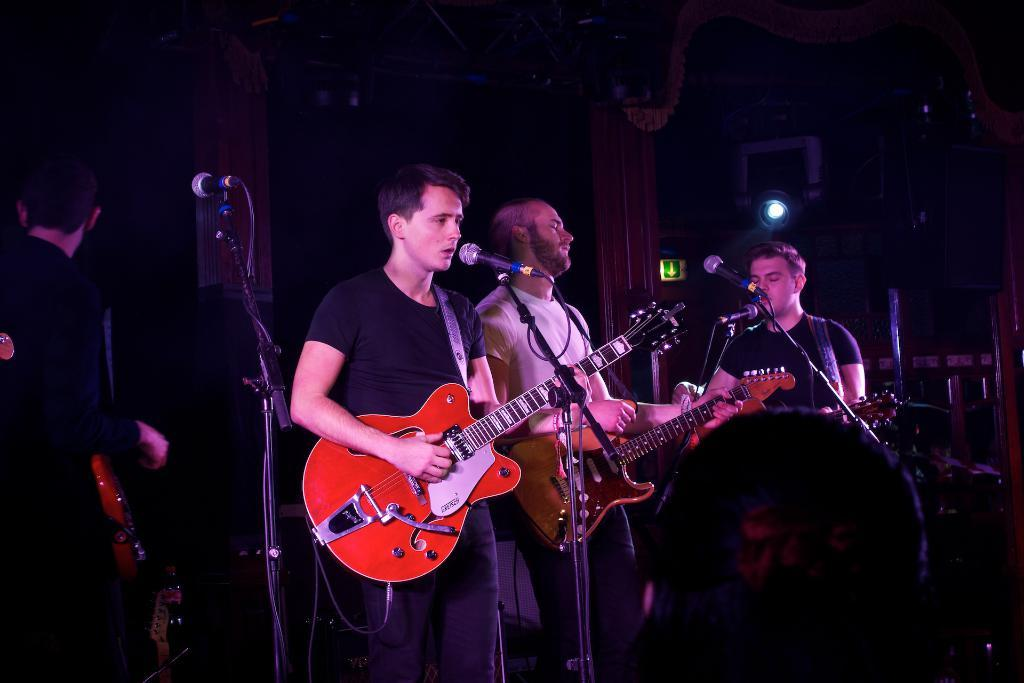What are the people in the image doing? There are people standing in the image, and some of them are playing guitar. Is there any vocalist in the image? Yes, there is a man singing in the image. How is the man singing? The man is using a microphone while singing. What type of drink is the man holding while singing? There is no drink visible in the image; the man is using a microphone while singing. Can you see any wax figures in the image? There are no wax figures present in the image; it features people playing music and singing. 